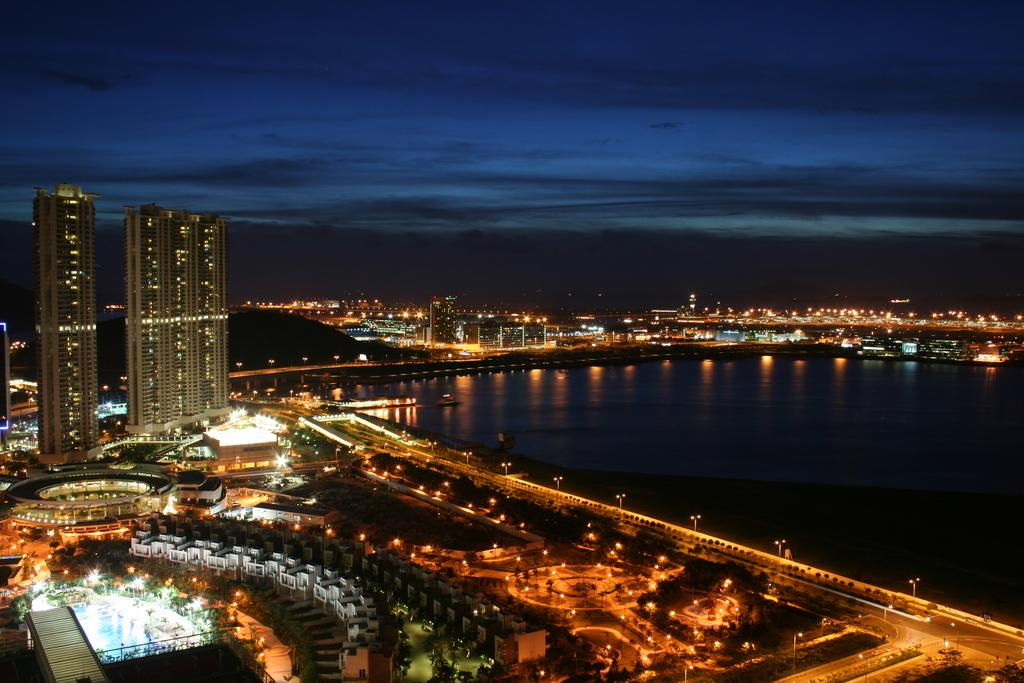What type of structures can be seen in the image? There are buildings in the image. What natural elements are present in the image? There are trees in the image. What man-made objects can be seen in the image? There are poles in the image. What is the source of illumination in the image? There are lights in the image. What can be seen flowing or reflecting in the image? There is water visible in the image. What is visible in the background of the image? The sky is visible in the background of the image, and there are clouds in the sky. How many women are singing songs in the image? There are no women or songs present in the image. What type of system is responsible for the water flow in the image? There is no system mentioned or visible in the image related to the water flow. 